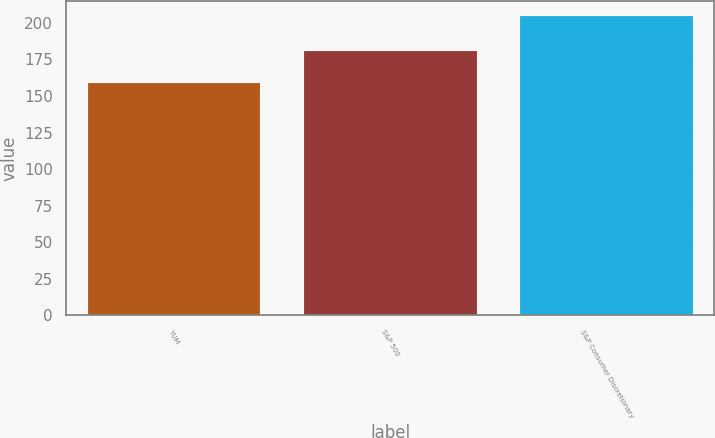<chart> <loc_0><loc_0><loc_500><loc_500><bar_chart><fcel>YUM<fcel>S&P 500<fcel>S&P Consumer Discretionary<nl><fcel>159<fcel>181<fcel>205<nl></chart> 